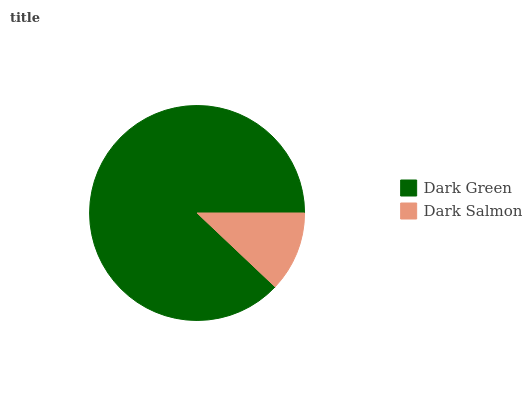Is Dark Salmon the minimum?
Answer yes or no. Yes. Is Dark Green the maximum?
Answer yes or no. Yes. Is Dark Salmon the maximum?
Answer yes or no. No. Is Dark Green greater than Dark Salmon?
Answer yes or no. Yes. Is Dark Salmon less than Dark Green?
Answer yes or no. Yes. Is Dark Salmon greater than Dark Green?
Answer yes or no. No. Is Dark Green less than Dark Salmon?
Answer yes or no. No. Is Dark Green the high median?
Answer yes or no. Yes. Is Dark Salmon the low median?
Answer yes or no. Yes. Is Dark Salmon the high median?
Answer yes or no. No. Is Dark Green the low median?
Answer yes or no. No. 